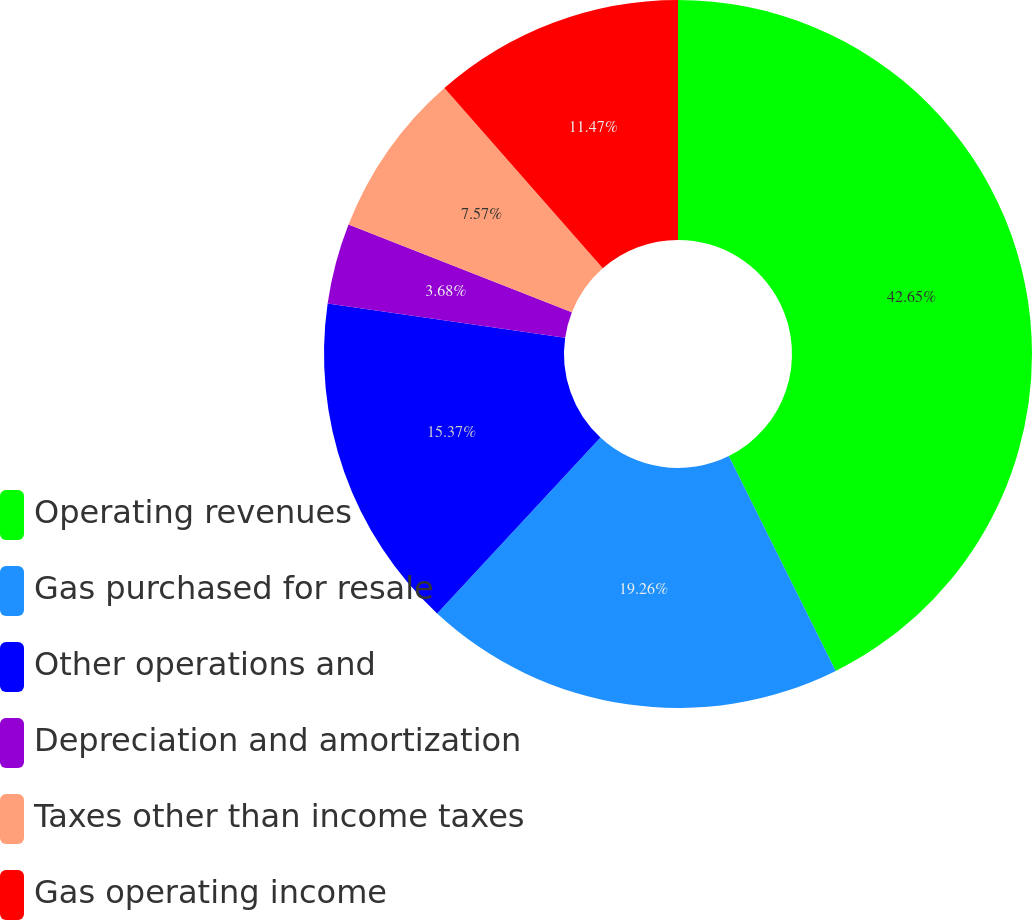<chart> <loc_0><loc_0><loc_500><loc_500><pie_chart><fcel>Operating revenues<fcel>Gas purchased for resale<fcel>Other operations and<fcel>Depreciation and amortization<fcel>Taxes other than income taxes<fcel>Gas operating income<nl><fcel>42.65%<fcel>19.26%<fcel>15.37%<fcel>3.68%<fcel>7.57%<fcel>11.47%<nl></chart> 